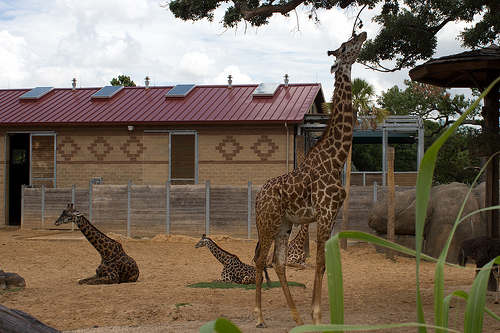Describe the scene if it were taking place at night with glowing lights. As night falls, the zoo takes on an enchanting glow. The red roof of the building is subtly illuminated by soft, ambient lights, reflecting a warm, inviting hue. Moonlight filters through the trees, casting playful shadows on the ground. The solar panels, now inactive, shimmer slightly under the moon's gentle light. The giraffes, silhouetted against the dimly lit enclosure, appear serene and otherworldly. Their coats, faintly illuminated by the artificial lights, create a mesmerizing pattern of spots and shadows. This tranquil night scene of the zoo, with its quiet elegance and understated glow, captures a sense of peace and mystery, painting a picture of nature's nocturnal beauty. 